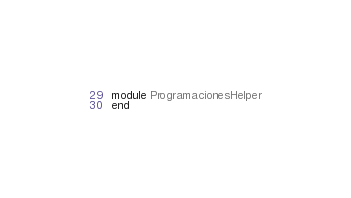Convert code to text. <code><loc_0><loc_0><loc_500><loc_500><_Ruby_>module ProgramacionesHelper
end
</code> 